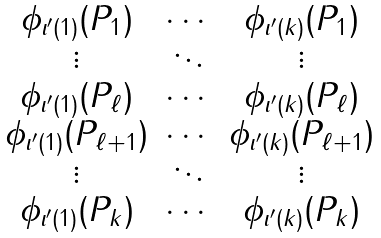<formula> <loc_0><loc_0><loc_500><loc_500>\begin{matrix} \phi _ { \iota ^ { \prime } ( 1 ) } ( P _ { 1 } ) & \cdots & \phi _ { \iota ^ { \prime } ( k ) } ( P _ { 1 } ) \\ \vdots & \ddots & \vdots \\ \phi _ { \iota ^ { \prime } ( 1 ) } ( P _ { \ell } ) & \cdots & \phi _ { \iota ^ { \prime } ( k ) } ( P _ { \ell } ) \\ \phi _ { \iota ^ { \prime } ( 1 ) } ( P _ { \ell + 1 } ) & \cdots & \phi _ { \iota ^ { \prime } ( k ) } ( P _ { \ell + 1 } ) \\ \vdots & \ddots & \vdots \\ \phi _ { \iota ^ { \prime } ( 1 ) } ( P _ { k } ) & \cdots & \phi _ { \iota ^ { \prime } ( k ) } ( P _ { k } ) \end{matrix}</formula> 